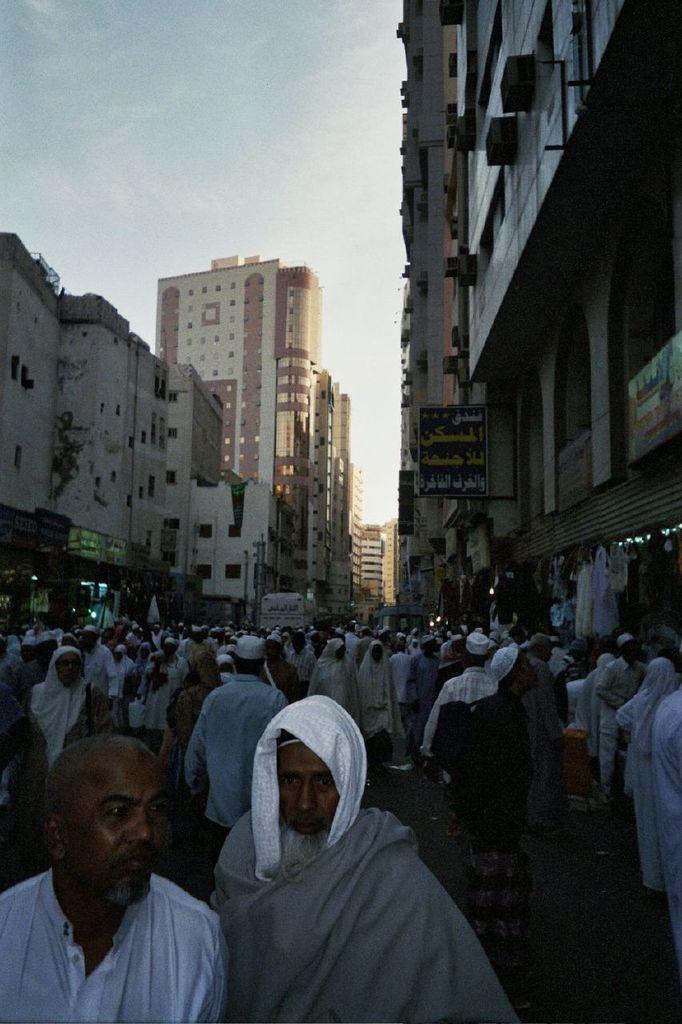Describe this image in one or two sentences. This picture is clicked outside. In the foreground we can see the group of people and on both the sides we can see the buildings and the text on the boards and we can see the lights. In the background we can see the sky. On the right we can see a person wearing a backpack and standing on the ground. 